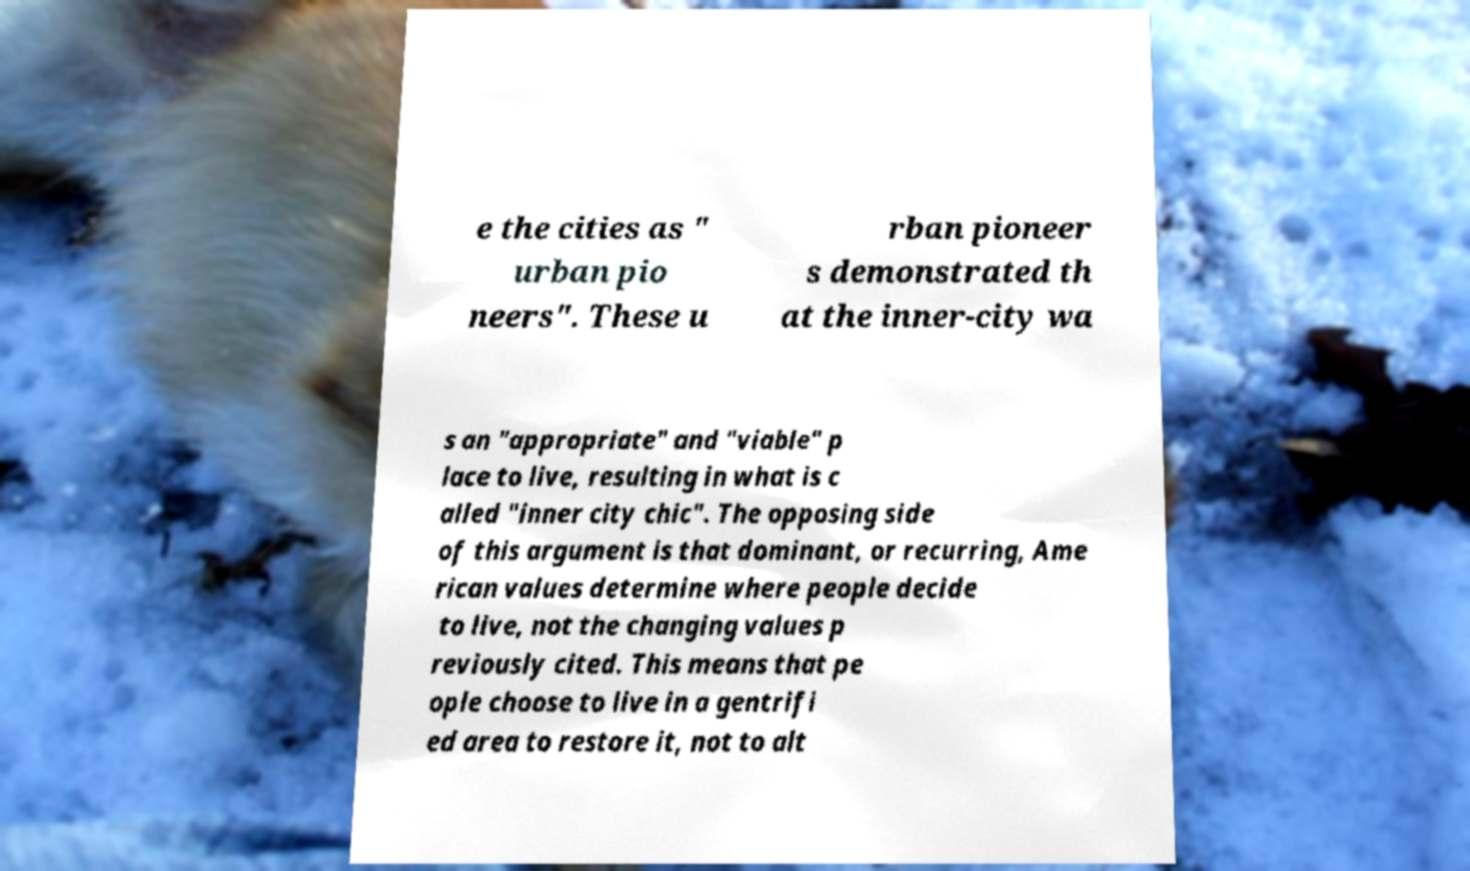Could you extract and type out the text from this image? e the cities as " urban pio neers". These u rban pioneer s demonstrated th at the inner-city wa s an "appropriate" and "viable" p lace to live, resulting in what is c alled "inner city chic". The opposing side of this argument is that dominant, or recurring, Ame rican values determine where people decide to live, not the changing values p reviously cited. This means that pe ople choose to live in a gentrifi ed area to restore it, not to alt 